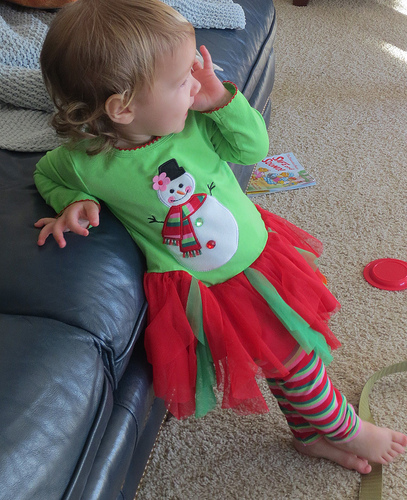<image>
Is there a book under the sofa? Yes. The book is positioned underneath the sofa, with the sofa above it in the vertical space. Where is the girl in relation to the couch? Is it behind the couch? No. The girl is not behind the couch. From this viewpoint, the girl appears to be positioned elsewhere in the scene. Is there a sofa in front of the girl? No. The sofa is not in front of the girl. The spatial positioning shows a different relationship between these objects. Is the girl above the couch? No. The girl is not positioned above the couch. The vertical arrangement shows a different relationship. 